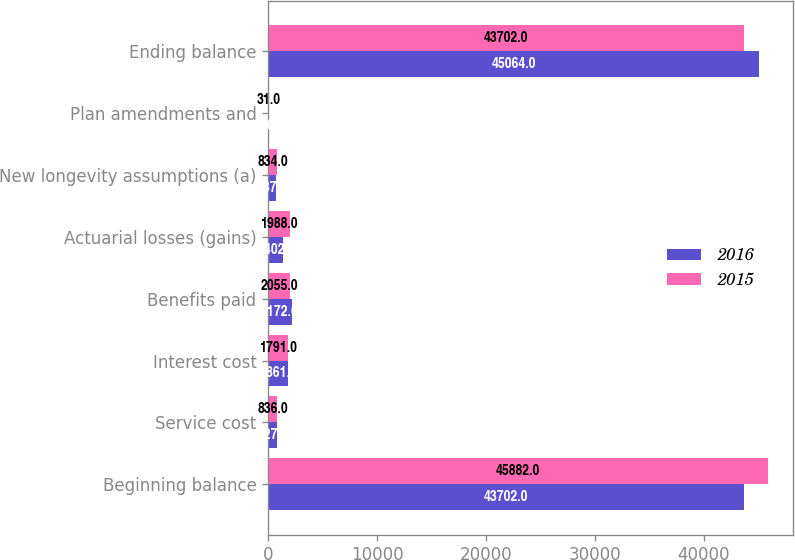<chart> <loc_0><loc_0><loc_500><loc_500><stacked_bar_chart><ecel><fcel>Beginning balance<fcel>Service cost<fcel>Interest cost<fcel>Benefits paid<fcel>Actuarial losses (gains)<fcel>New longevity assumptions (a)<fcel>Plan amendments and<fcel>Ending balance<nl><fcel>2016<fcel>43702<fcel>827<fcel>1861<fcel>2172<fcel>1402<fcel>687<fcel>110<fcel>45064<nl><fcel>2015<fcel>45882<fcel>836<fcel>1791<fcel>2055<fcel>1988<fcel>834<fcel>31<fcel>43702<nl></chart> 